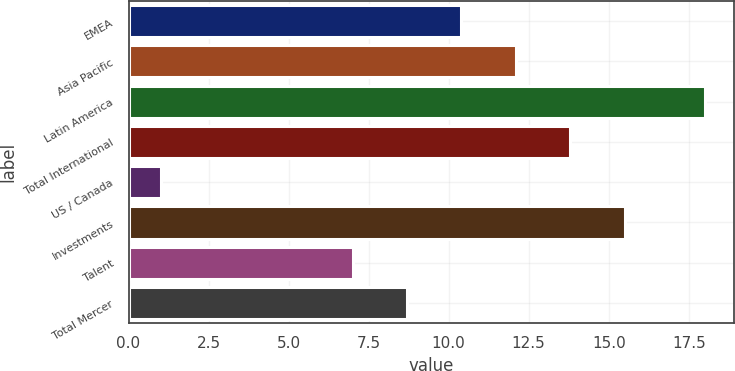Convert chart to OTSL. <chart><loc_0><loc_0><loc_500><loc_500><bar_chart><fcel>EMEA<fcel>Asia Pacific<fcel>Latin America<fcel>Total International<fcel>US / Canada<fcel>Investments<fcel>Talent<fcel>Total Mercer<nl><fcel>10.4<fcel>12.1<fcel>18<fcel>13.8<fcel>1<fcel>15.5<fcel>7<fcel>8.7<nl></chart> 